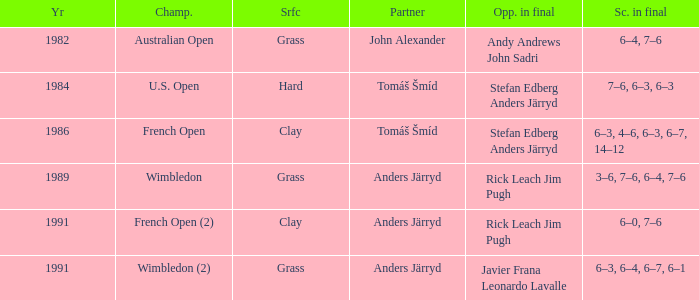Who was his partner in 1989?  Anders Järryd. 